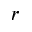Convert formula to latex. <formula><loc_0><loc_0><loc_500><loc_500>{ r }</formula> 